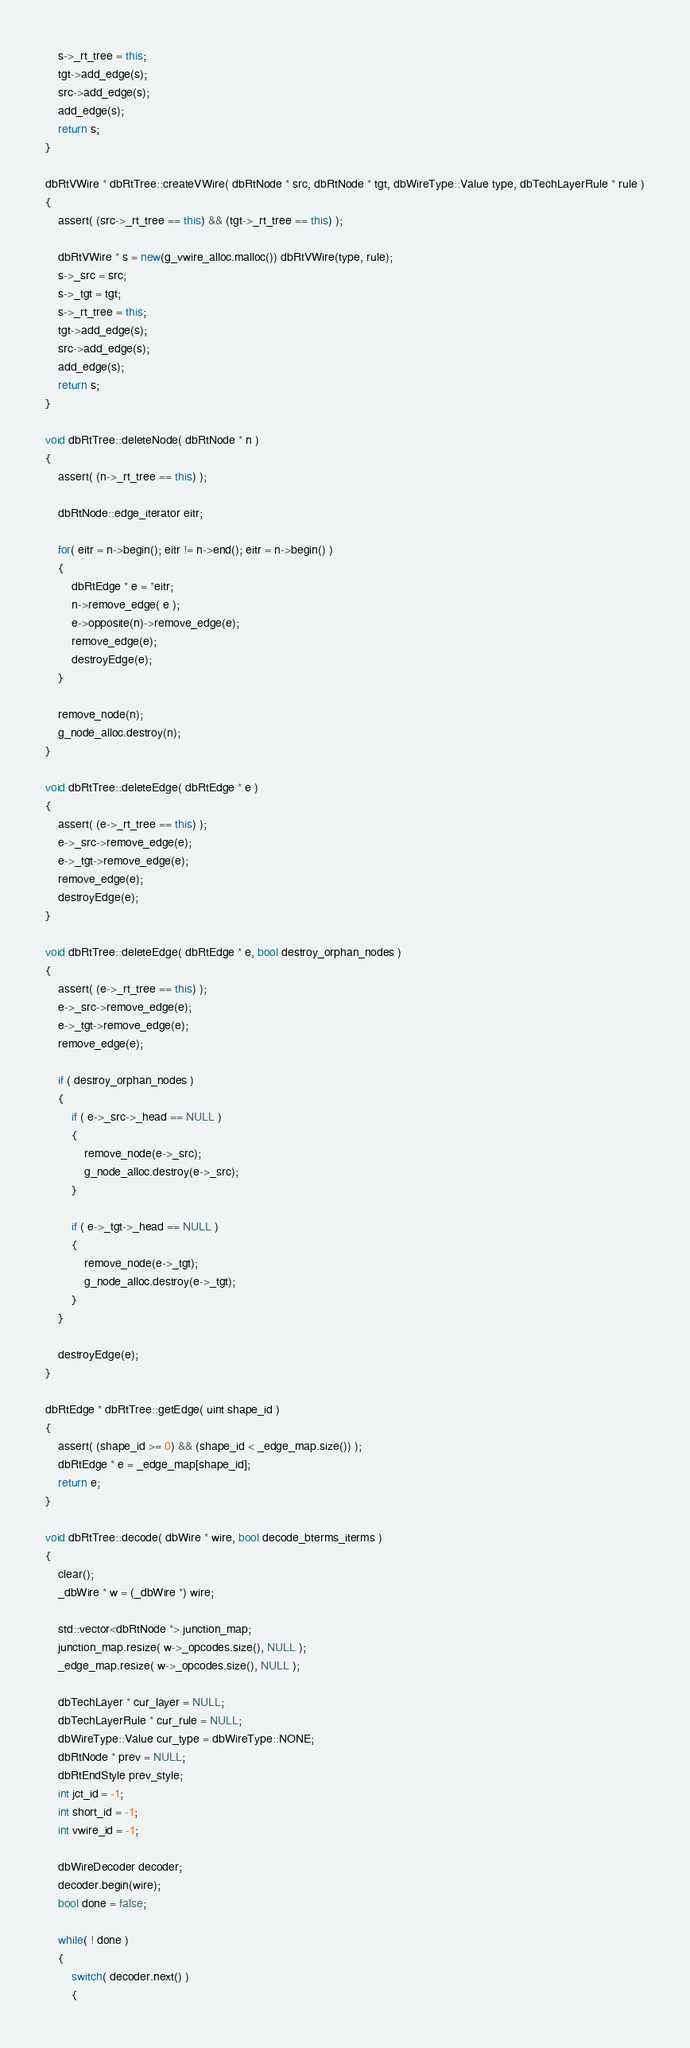Convert code to text. <code><loc_0><loc_0><loc_500><loc_500><_C++_>    s->_rt_tree = this;
    tgt->add_edge(s);
    src->add_edge(s);
    add_edge(s);
    return s;
}

dbRtVWire * dbRtTree::createVWire( dbRtNode * src, dbRtNode * tgt, dbWireType::Value type, dbTechLayerRule * rule )
{
    assert( (src->_rt_tree == this) && (tgt->_rt_tree == this) );
    
    dbRtVWire * s = new(g_vwire_alloc.malloc()) dbRtVWire(type, rule);
    s->_src = src;
    s->_tgt = tgt;
    s->_rt_tree = this;
    tgt->add_edge(s);
    src->add_edge(s);
    add_edge(s);
    return s;
}

void dbRtTree::deleteNode( dbRtNode * n )
{
    assert( (n->_rt_tree == this) );

    dbRtNode::edge_iterator eitr;

    for( eitr = n->begin(); eitr != n->end(); eitr = n->begin() )
    {
        dbRtEdge * e = *eitr;
        n->remove_edge( e );
        e->opposite(n)->remove_edge(e);
        remove_edge(e);
        destroyEdge(e);
    }

    remove_node(n);
    g_node_alloc.destroy(n);
}

void dbRtTree::deleteEdge( dbRtEdge * e )
{
    assert( (e->_rt_tree == this) );
    e->_src->remove_edge(e);
    e->_tgt->remove_edge(e);
    remove_edge(e);
    destroyEdge(e);
}

void dbRtTree::deleteEdge( dbRtEdge * e, bool destroy_orphan_nodes )
{
    assert( (e->_rt_tree == this) );
    e->_src->remove_edge(e);
    e->_tgt->remove_edge(e);
    remove_edge(e);

    if ( destroy_orphan_nodes )
    {
        if ( e->_src->_head == NULL )
        {
            remove_node(e->_src);
            g_node_alloc.destroy(e->_src);
        }

        if ( e->_tgt->_head == NULL )
        {
            remove_node(e->_tgt);
            g_node_alloc.destroy(e->_tgt);
        }
    }

    destroyEdge(e);
}

dbRtEdge * dbRtTree::getEdge( uint shape_id )
{
    assert( (shape_id >= 0) && (shape_id < _edge_map.size()) );
    dbRtEdge * e = _edge_map[shape_id];
    return e;
}

void dbRtTree::decode( dbWire * wire, bool decode_bterms_iterms )
{
    clear();
    _dbWire * w = (_dbWire *) wire;

    std::vector<dbRtNode *> junction_map;
    junction_map.resize( w->_opcodes.size(), NULL );
    _edge_map.resize( w->_opcodes.size(), NULL );
    
    dbTechLayer * cur_layer = NULL;
    dbTechLayerRule * cur_rule = NULL;
    dbWireType::Value cur_type = dbWireType::NONE;
    dbRtNode * prev = NULL;
    dbRtEndStyle prev_style;
    int jct_id = -1;
    int short_id = -1;
    int vwire_id = -1;

    dbWireDecoder decoder;
    decoder.begin(wire);
    bool done = false;

    while( ! done )
    {
        switch( decoder.next() )
        {</code> 